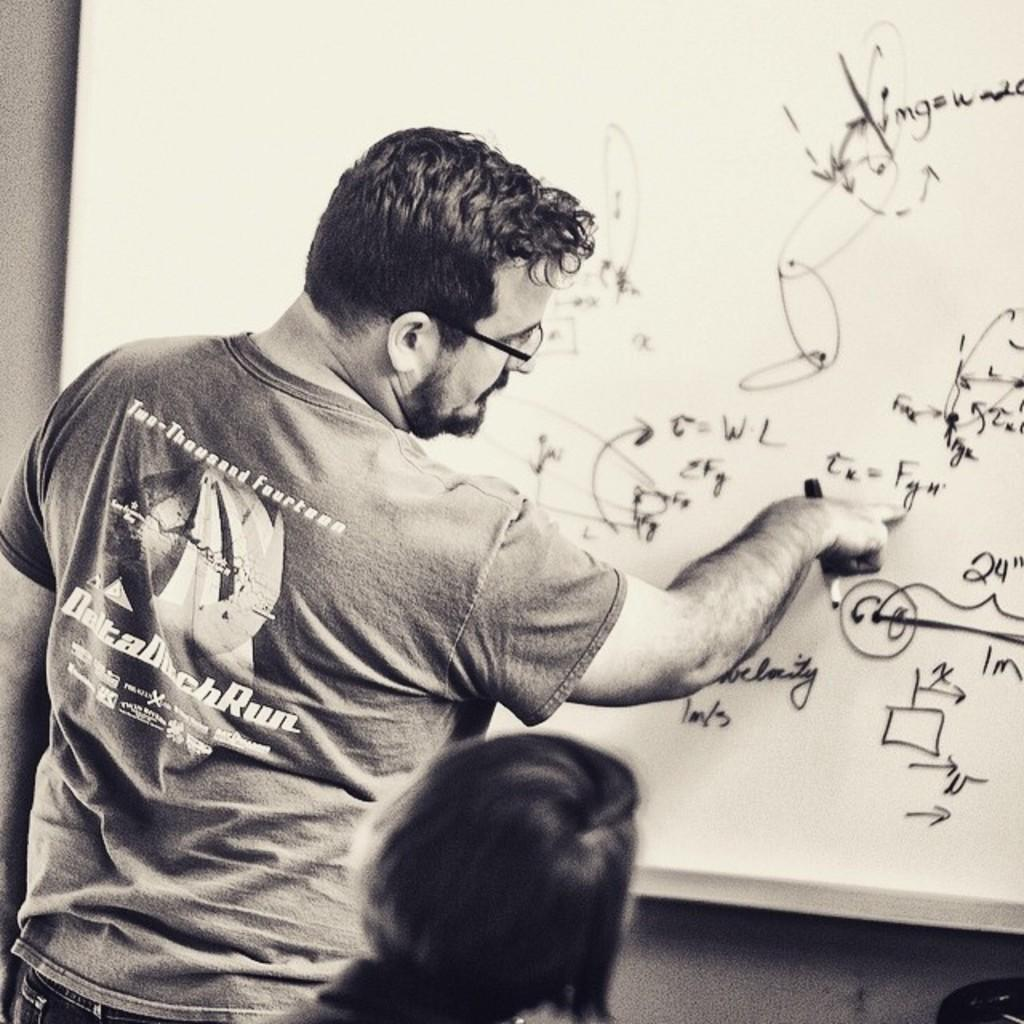Provide a one-sentence caption for the provided image. A man wearing a 2014 Delta Duck Run shirt writing on a whiteboard. 